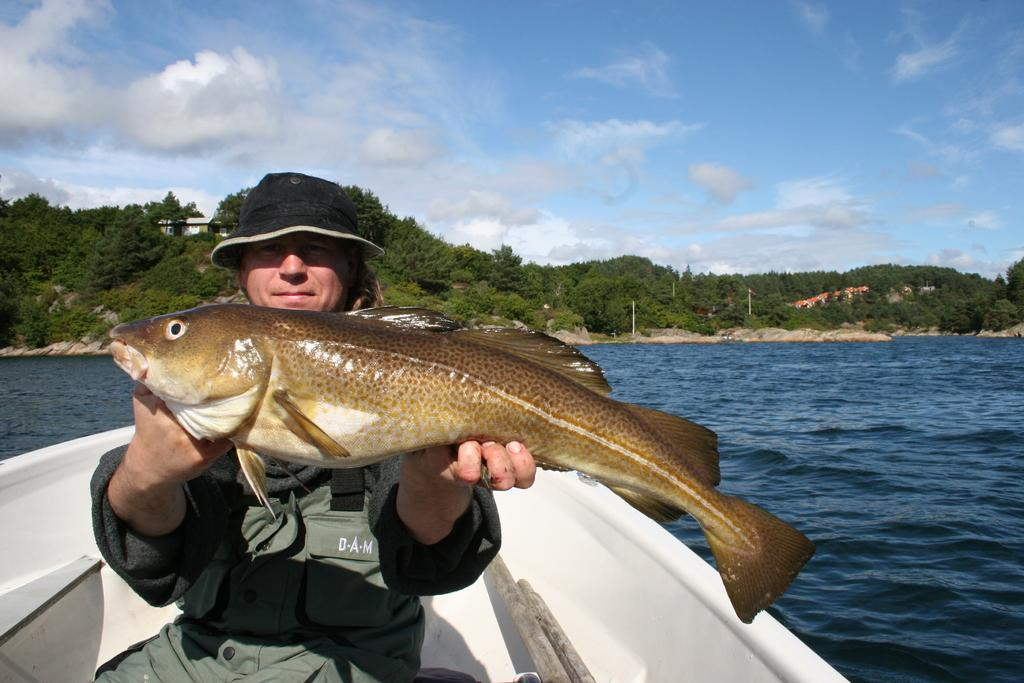What is the person in the image holding? The person is holding a fish. Where is the person located in the image? The person is in a boat. What can be seen in the background of the image? There is a hill, a building, poles, water, and the sky visible in the background of the image. What is the condition of the sky in the image? The sky is visible in the background of the image, and there are clouds present. What type of yard can be seen in the image? There is no yard present in the image; it features a person in a boat holding a fish, with a background that includes a hill, a building, poles, water, and the sky. 